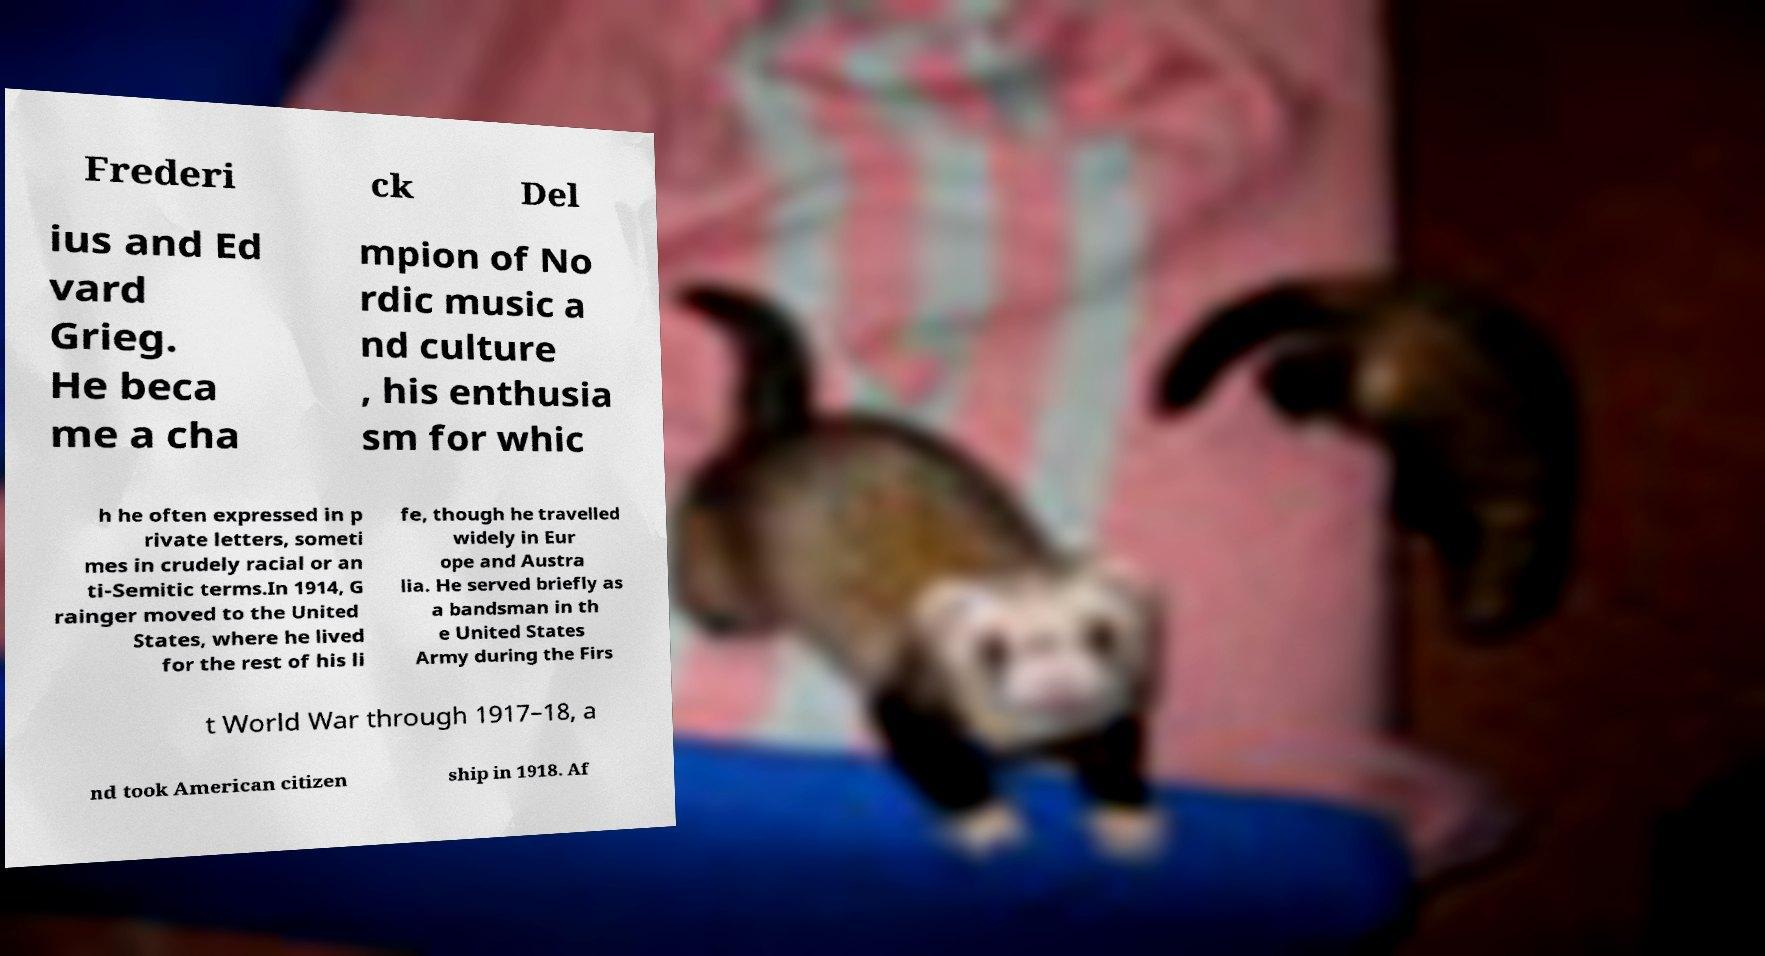Could you assist in decoding the text presented in this image and type it out clearly? Frederi ck Del ius and Ed vard Grieg. He beca me a cha mpion of No rdic music a nd culture , his enthusia sm for whic h he often expressed in p rivate letters, someti mes in crudely racial or an ti-Semitic terms.In 1914, G rainger moved to the United States, where he lived for the rest of his li fe, though he travelled widely in Eur ope and Austra lia. He served briefly as a bandsman in th e United States Army during the Firs t World War through 1917–18, a nd took American citizen ship in 1918. Af 